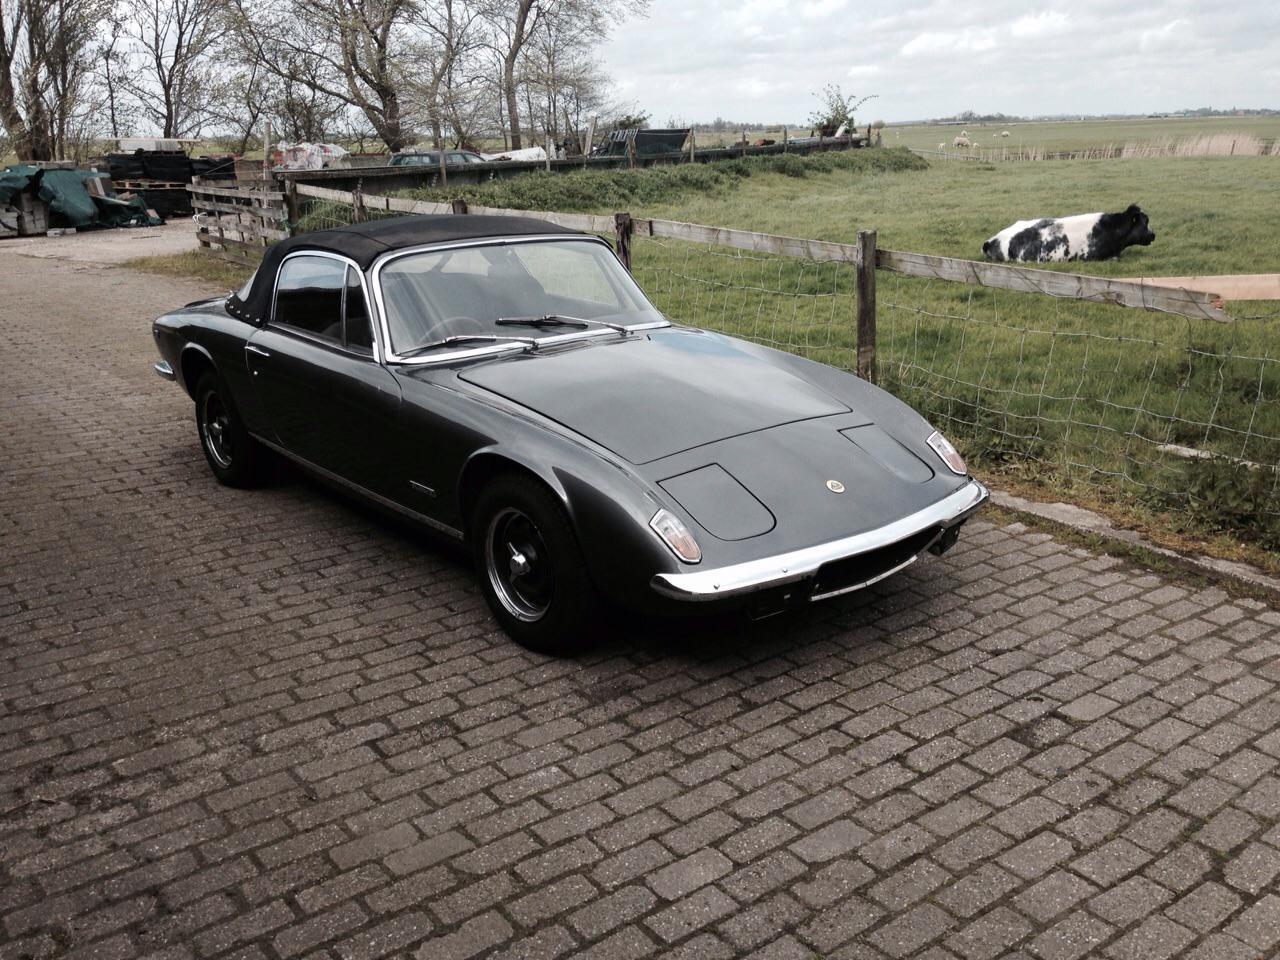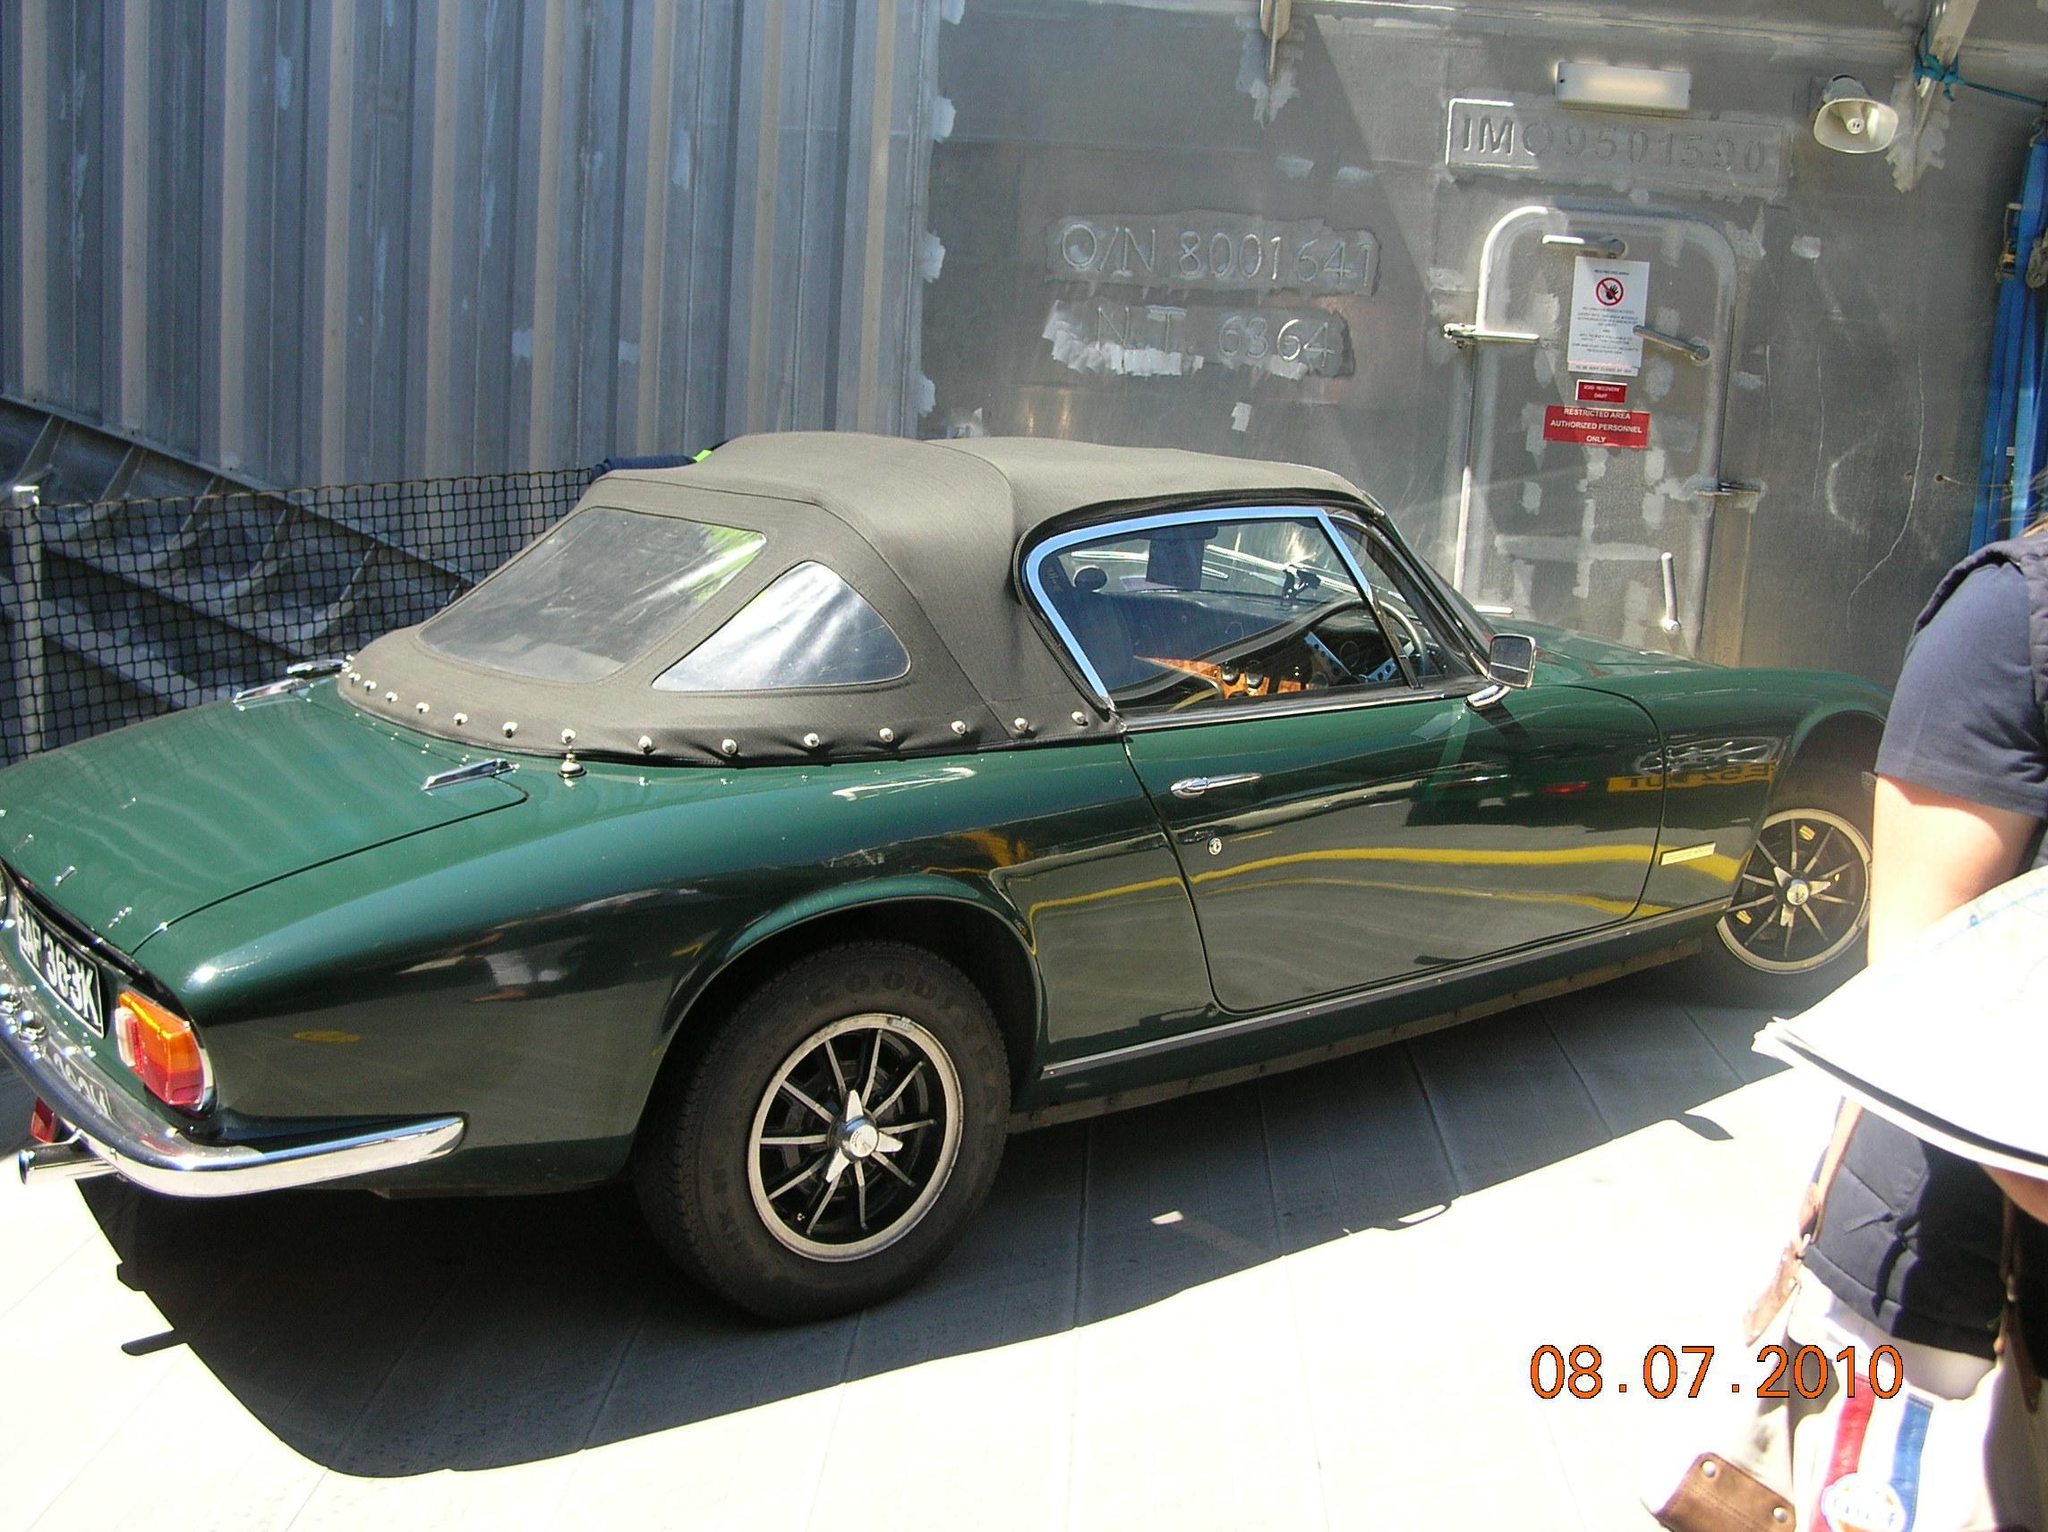The first image is the image on the left, the second image is the image on the right. Examine the images to the left and right. Is the description "One image shows a blue convertible with the top down." accurate? Answer yes or no. No. 